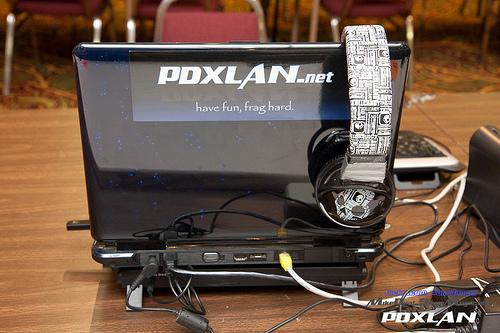Can you tell me the overall sentiment of the image? Is it a happy, busy or a negative scene? The scene in the image appears to be busy with multiple objects and cables. What color is the chair and what element can you see on the back of it? The chair is red with a cushion, and the back of a red chair can be seen. How many small green plants are in the image? There are no small green plants in the image. Explain the relationship between the headphones and their surroundings. The headphones are placed on the table, surrounded by various tech gadgets and cables, indicating a tech-focused environment. What is the condition of the cables in the image? The cables are jumbled up. Can you locate the vintage rotary phone on the image? It has an elegant design with an old-fashioned telephone dial. Yes, the vintage rotary phone is on the right side of the laptop, resting against the monitor. What color is the sticker on the laptop? The sticker on the laptop is white. Based on the details in the image, which of the following is true? b) A power cable is plugged into the laptop What type of event is happening in the image? Specify the action. There is no specific event occurring, but a workspace is set up with various gadgets and equipment. Write a poem about the scene in the image, appealing to the senses. Upon a wooden platform made of oak, Is the USB stick plugged into the laptop? Yes Which object is located at the back of the laptop monitor? b) Power cord What objects can you find on this wooden table? Laptop, headphones, telephone, USB stick, power cord, Ethernet cable, and wires How is the red chair related to the table? The chair is placed at the table. Does the table appear to be made of wood or metal? Wood 